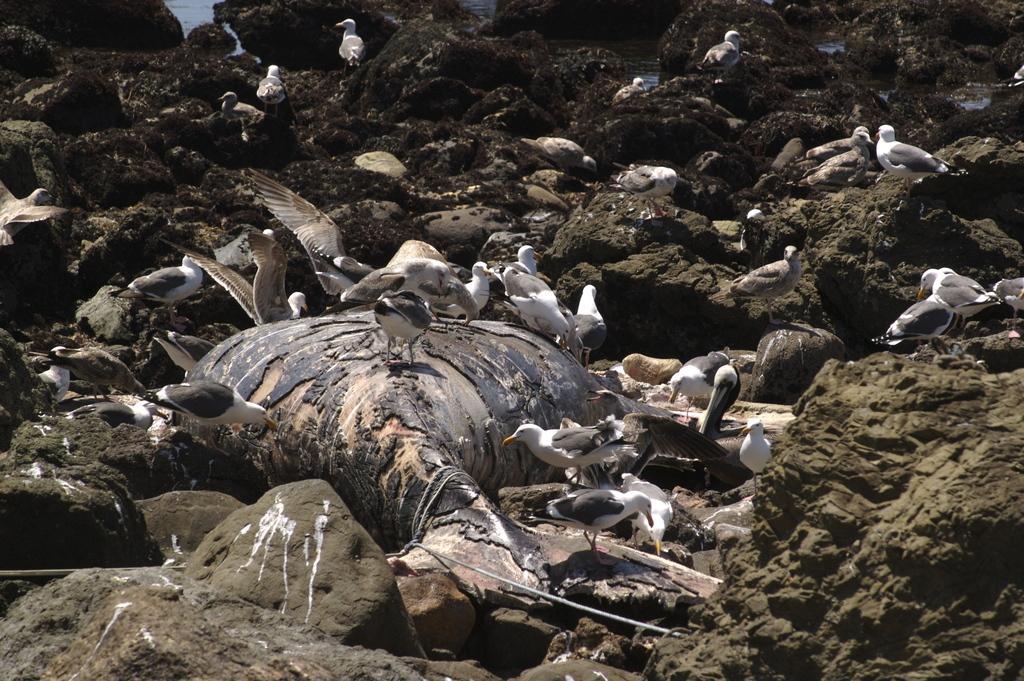Please provide a concise description of this image. In the center of the image there is a dead animal. There are birds. There are rocks. 